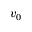<formula> <loc_0><loc_0><loc_500><loc_500>v _ { 0 }</formula> 